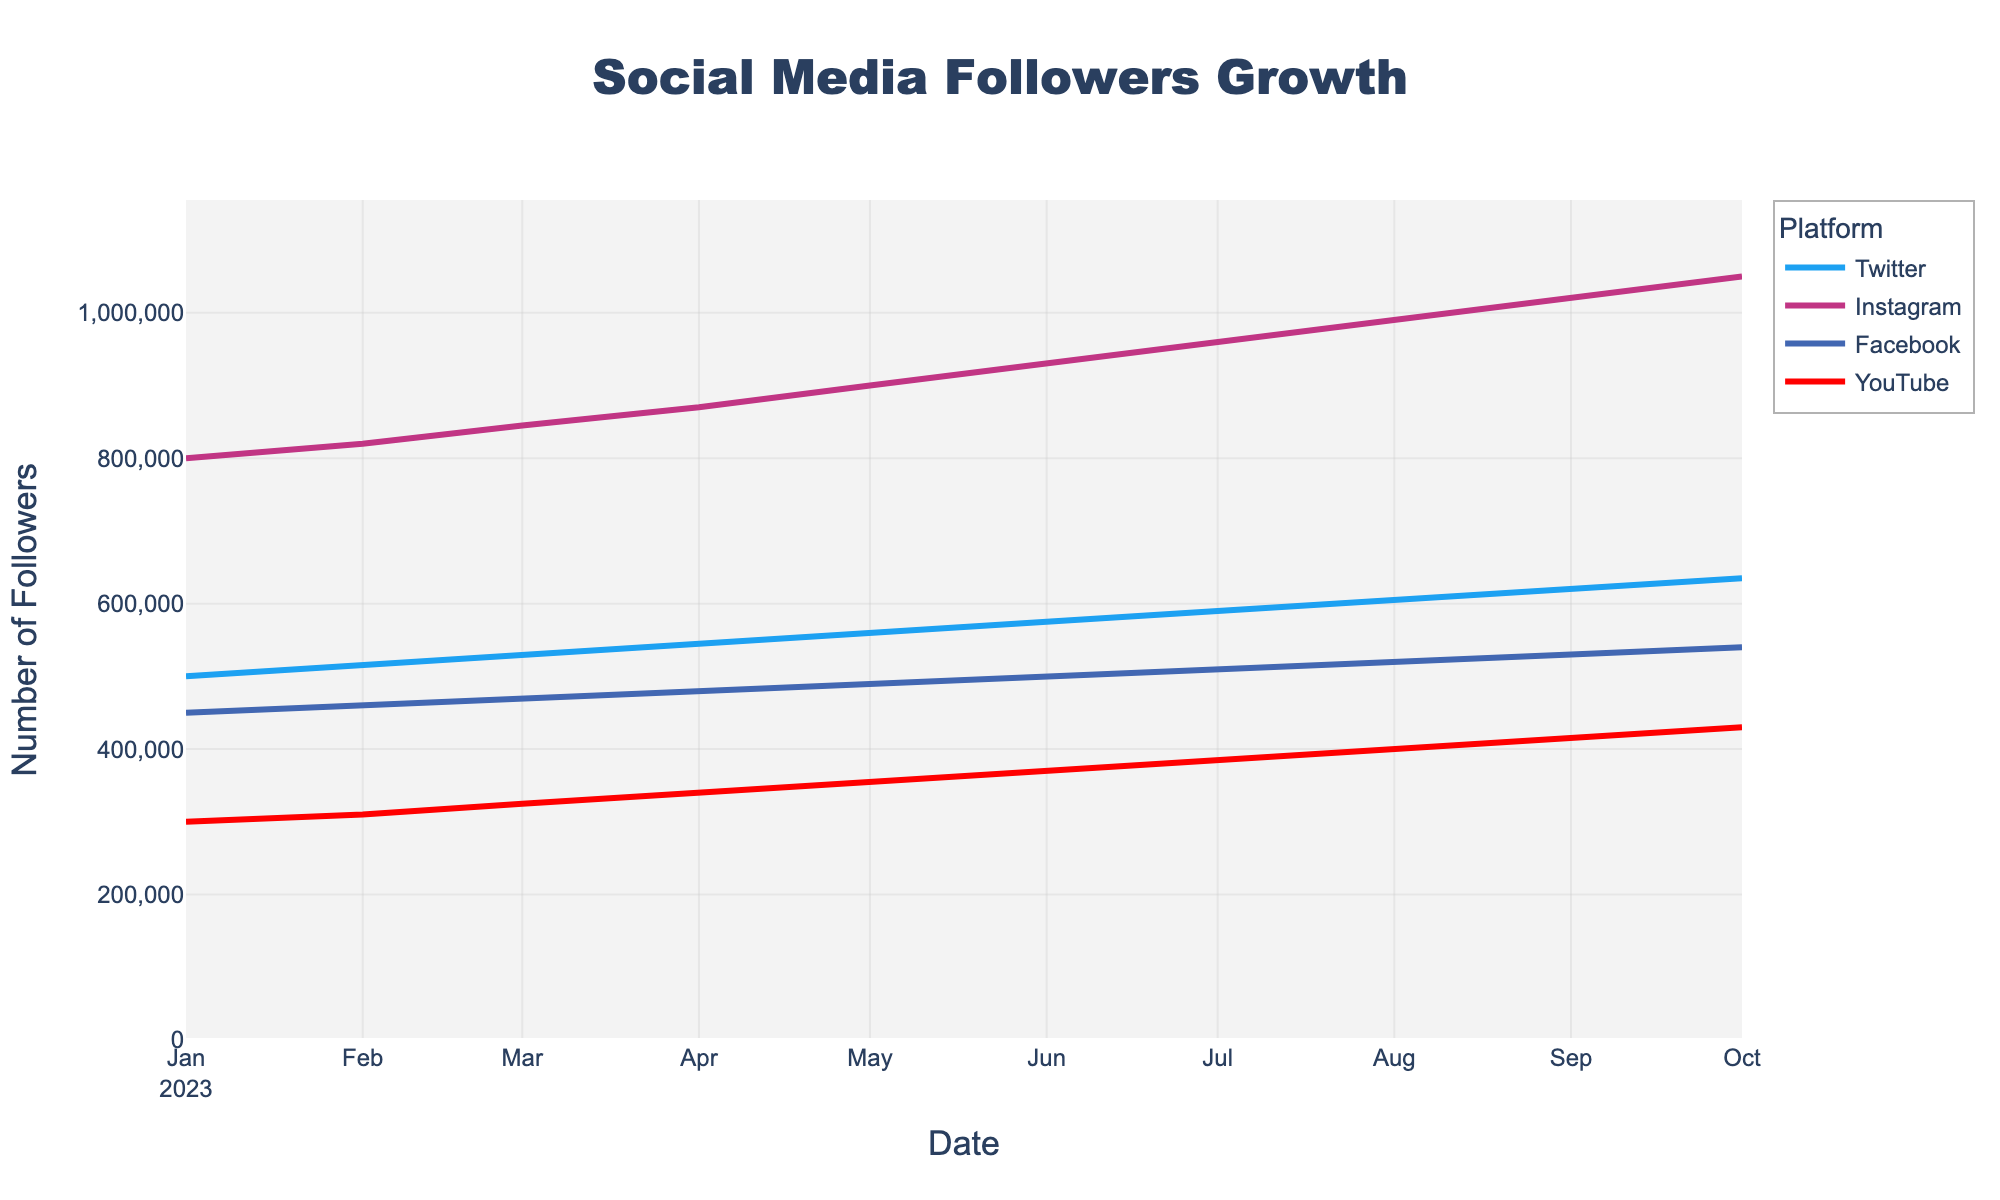What is the title of the plot? The title can be found at the top of the plot. It summarizes the data presented. The title given is "Social Media Followers Growth".
Answer: Social Media Followers Growth Which platform had the most followers on October 1st, 2023? To determine this, look at the plotted points for October 1st, 2023, and compare the follower counts among the platforms. On this date, Instagram had the highest follower count.
Answer: Instagram How many followers did YouTube have in January 2023? Identify the data point for YouTube on January 1st, 2023, from the plot. YouTube had 300,000 followers in January 2023.
Answer: 300,000 Which platform showed the highest growth in followers from January 2023 to October 2023? To find this, calculate the difference in followers for each platform between January and October 2023, then compare these values. Instagram grew from 800,000 to 1,050,000, which is a growth of 250,000 followers, the highest among the platforms.
Answer: Instagram What was the total number of followers on Facebook by September 2023? Look for the data point representing Facebook in September 2023. The total number of followers is 530,000.
Answer: 530,000 Compare the number of followers Twitter had between March and August 2023. Identify the Twitter data points for March and August 2023. In March, Twitter had 530,000 followers and in August, 605,000. The difference is 605,000 - 530,000 = 75,000 followers.
Answer: 75,000 difference What was the average number of followers for YouTube from January to October 2023? Add up YouTube's followers for each month and divide by the number of months. (300,000 + 310,000 + 325,000 + 340,000 + 355,000 + 370,000 + 385,000 + 400,000 + 415,000 + 430,000) / 10 = 360,000.
Answer: 360,000 Between February and July 2023, which platform's followers count increased the least? Calculate the followers increase for each platform between February and July 2023:
- Twitter: 590,000 - 515,000 = 75,000
- Instagram: 960,000 - 820,000 = 140,000
- Facebook: 510,000 - 460,000 = 50,000
- YouTube: 385,000 - 310,000 = 75,000
Facebook has the least increase with 50,000 followers.
Answer: Facebook 